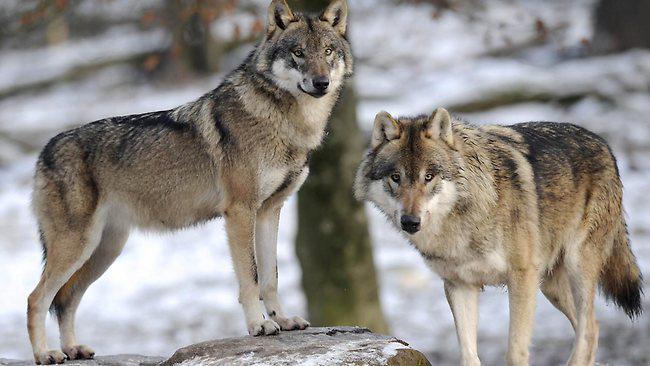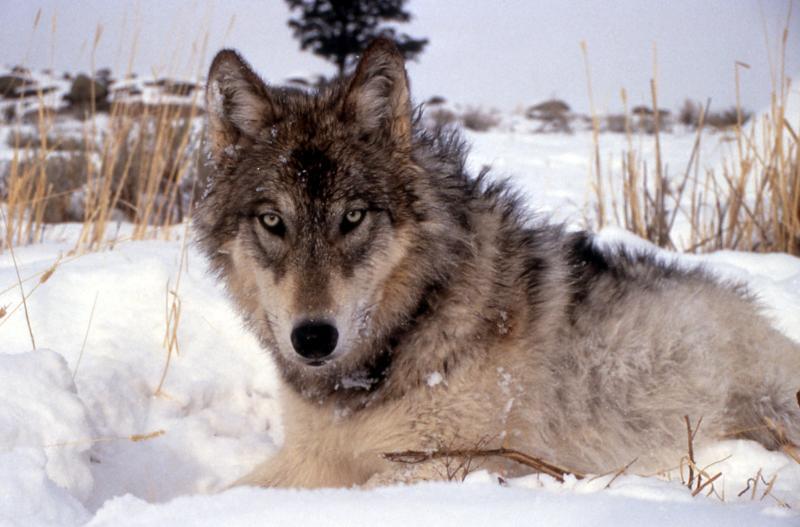The first image is the image on the left, the second image is the image on the right. Examine the images to the left and right. Is the description "One image includes exactly twice as many wolves as the other image." accurate? Answer yes or no. Yes. The first image is the image on the left, the second image is the image on the right. Evaluate the accuracy of this statement regarding the images: "There are three wolves". Is it true? Answer yes or no. Yes. 